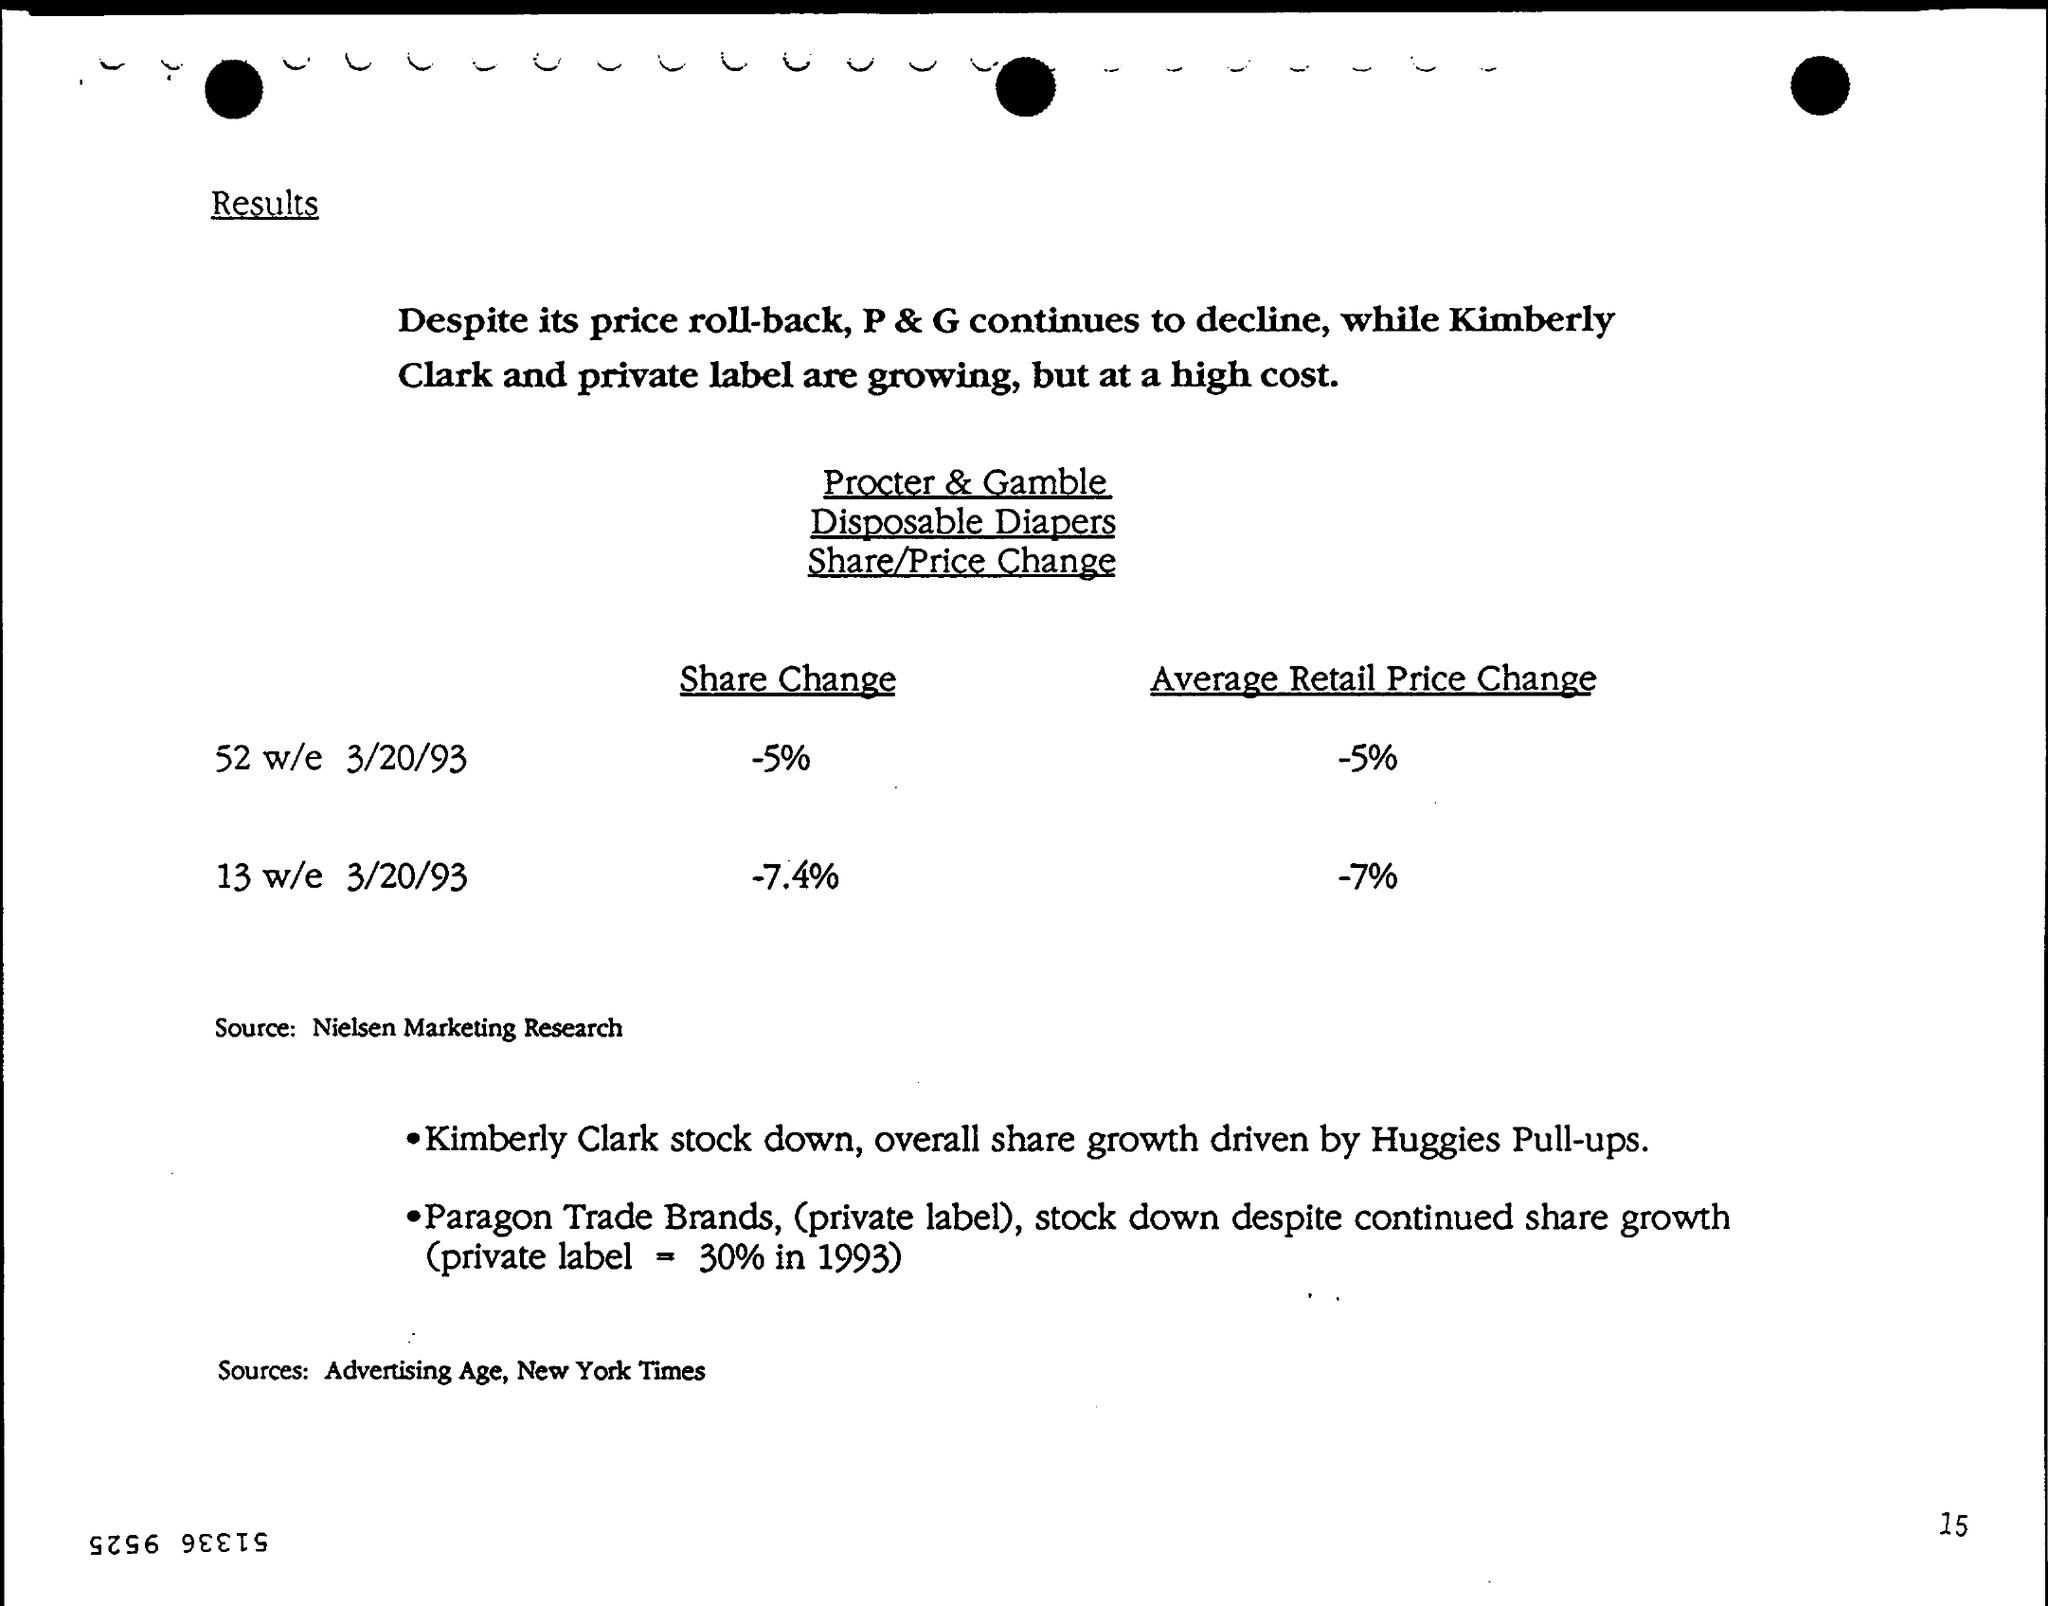Highlight a few significant elements in this photo. On the 13th week of the year 1993, there was a decrease of 7.4% in the share change. The average retail price changed by -5% for the 52 weeks ending on March 20, 1993. 